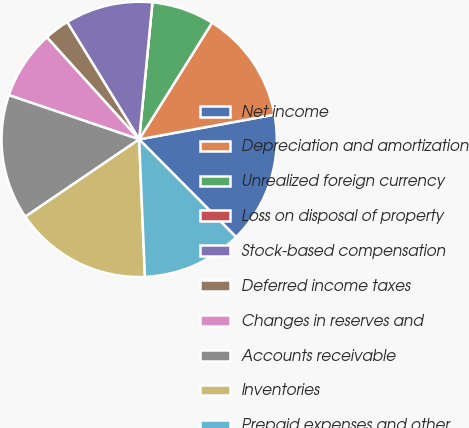Convert chart. <chart><loc_0><loc_0><loc_500><loc_500><pie_chart><fcel>Net income<fcel>Depreciation and amortization<fcel>Unrealized foreign currency<fcel>Loss on disposal of property<fcel>Stock-based compensation<fcel>Deferred income taxes<fcel>Changes in reserves and<fcel>Accounts receivable<fcel>Inventories<fcel>Prepaid expenses and other<nl><fcel>15.44%<fcel>13.23%<fcel>7.35%<fcel>0.0%<fcel>10.29%<fcel>2.94%<fcel>8.09%<fcel>14.7%<fcel>16.17%<fcel>11.76%<nl></chart> 